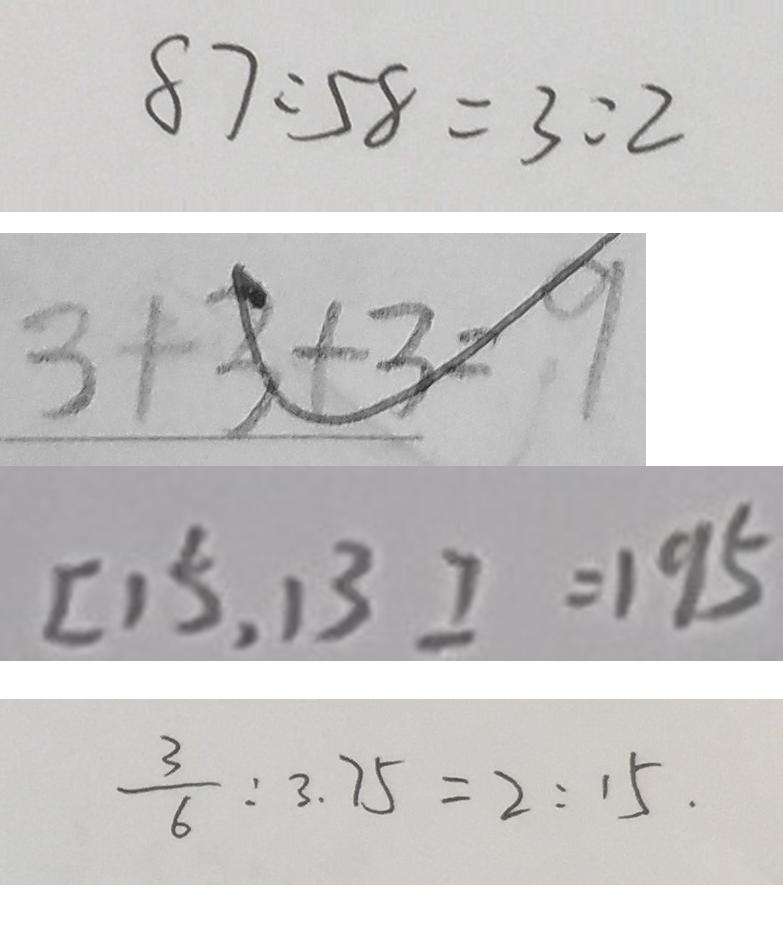Convert formula to latex. <formula><loc_0><loc_0><loc_500><loc_500>8 7 : 5 8 = 3 : 2 
 3 + 3 + 3 = 9 
 [ 1 5 , 1 3 ] = 1 9 5 
 \frac { 3 } { 6 } : 3 . 7 5 = 2 : 1 5 .</formula> 